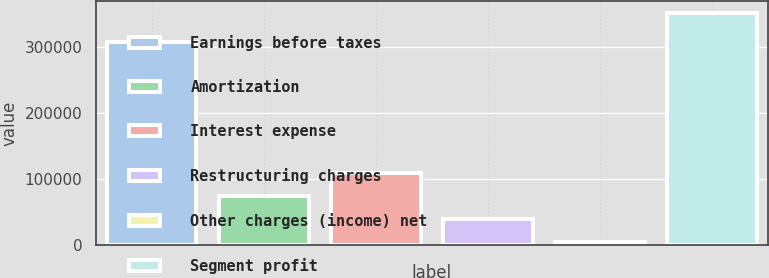Convert chart. <chart><loc_0><loc_0><loc_500><loc_500><bar_chart><fcel>Earnings before taxes<fcel>Amortization<fcel>Interest expense<fcel>Restructuring charges<fcel>Other charges (income) net<fcel>Segment profit<nl><fcel>307513<fcel>73619.6<fcel>108347<fcel>38891.8<fcel>4164<fcel>351442<nl></chart> 